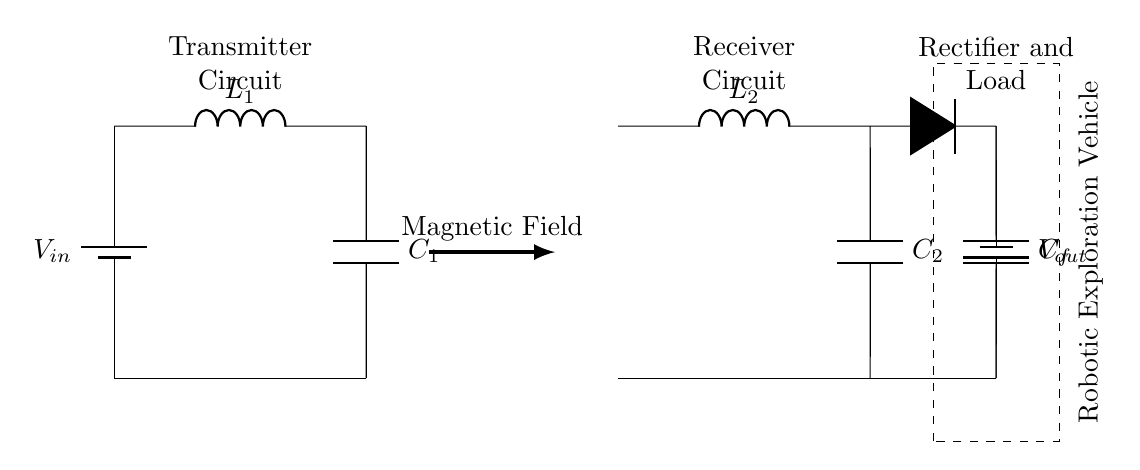What is the input voltage of the transmitter? The input voltage is indicated as V_in on the battery connected to the transmitter circuit.
Answer: V_in What is the function of the inductor L1? L1 is used to create a magnetic field, which is essential for wireless power transfer between the transmitter and receiver.
Answer: Create magnetic field What type of components are C1 and C2? C1 and C2 are capacitors, as indicated by their designation in the circuit diagram.
Answer: Capacitors What is the purpose of the rectifier in this circuit? The rectifier's purpose is to convert the alternating current generated by the receiver circuit into direct current, usable by the robotic vehicle's battery.
Answer: Convert AC to DC How many inductors are present in the circuit? There are two inductors present, one on the transmitter side (L1) and one on the receiver side (L2).
Answer: Two What does the dashed rectangle represent in this circuit diagram? The dashed rectangle represents the robotic exploration vehicle that is being powered by the charging circuit.
Answer: Robotic exploration vehicle What is the output voltage connected to? The output voltage is connected to the load, which in this case is the battery of the robotic vehicle.
Answer: Robotic vehicle battery 